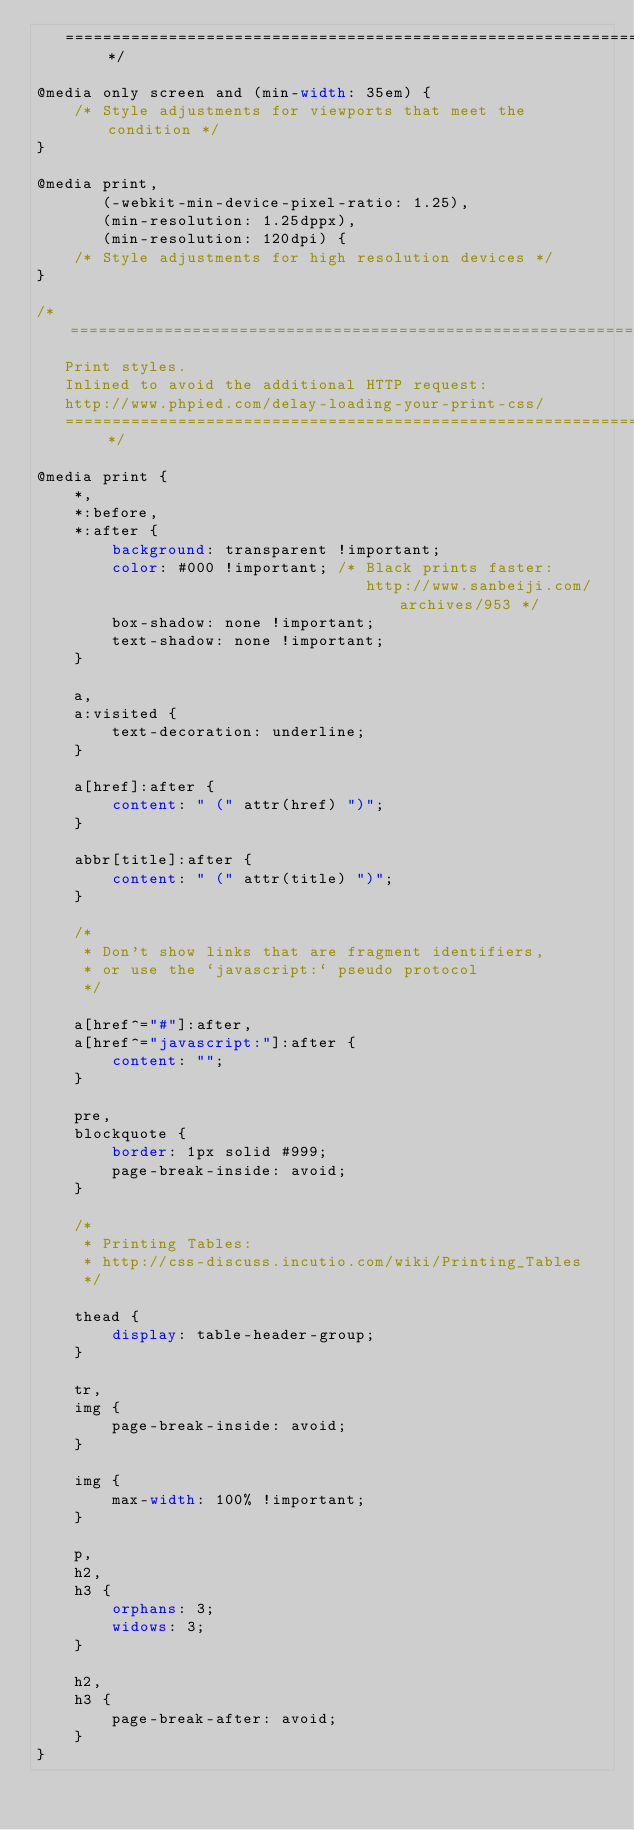<code> <loc_0><loc_0><loc_500><loc_500><_CSS_>   ========================================================================== */

@media only screen and (min-width: 35em) {
    /* Style adjustments for viewports that meet the condition */
}

@media print,
       (-webkit-min-device-pixel-ratio: 1.25),
       (min-resolution: 1.25dppx),
       (min-resolution: 120dpi) {
    /* Style adjustments for high resolution devices */
}

/* ==========================================================================
   Print styles.
   Inlined to avoid the additional HTTP request:
   http://www.phpied.com/delay-loading-your-print-css/
   ========================================================================== */

@media print {
    *,
    *:before,
    *:after {
        background: transparent !important;
        color: #000 !important; /* Black prints faster:
                                   http://www.sanbeiji.com/archives/953 */
        box-shadow: none !important;
        text-shadow: none !important;
    }

    a,
    a:visited {
        text-decoration: underline;
    }

    a[href]:after {
        content: " (" attr(href) ")";
    }

    abbr[title]:after {
        content: " (" attr(title) ")";
    }

    /*
     * Don't show links that are fragment identifiers,
     * or use the `javascript:` pseudo protocol
     */

    a[href^="#"]:after,
    a[href^="javascript:"]:after {
        content: "";
    }

    pre,
    blockquote {
        border: 1px solid #999;
        page-break-inside: avoid;
    }

    /*
     * Printing Tables:
     * http://css-discuss.incutio.com/wiki/Printing_Tables
     */

    thead {
        display: table-header-group;
    }

    tr,
    img {
        page-break-inside: avoid;
    }

    img {
        max-width: 100% !important;
    }

    p,
    h2,
    h3 {
        orphans: 3;
        widows: 3;
    }

    h2,
    h3 {
        page-break-after: avoid;
    }
}
</code> 